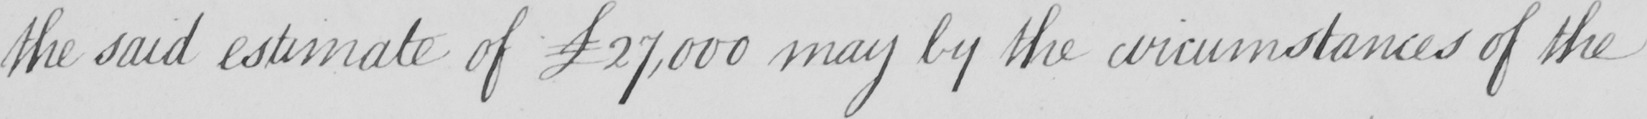What does this handwritten line say? the said estimate of  £27,000 may by the cirumstances of the 